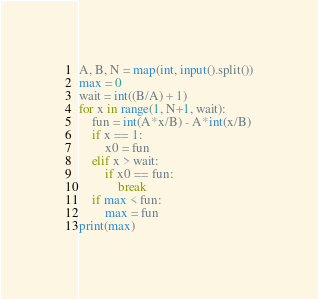<code> <loc_0><loc_0><loc_500><loc_500><_Python_>A, B, N = map(int, input().split())
max = 0
wait = int((B/A) + 1)
for x in range(1, N+1, wait):
    fun = int(A*x/B) - A*int(x/B)
    if x == 1:
        x0 = fun
    elif x > wait:
        if x0 == fun:
            break
    if max < fun:
        max = fun
print(max)</code> 